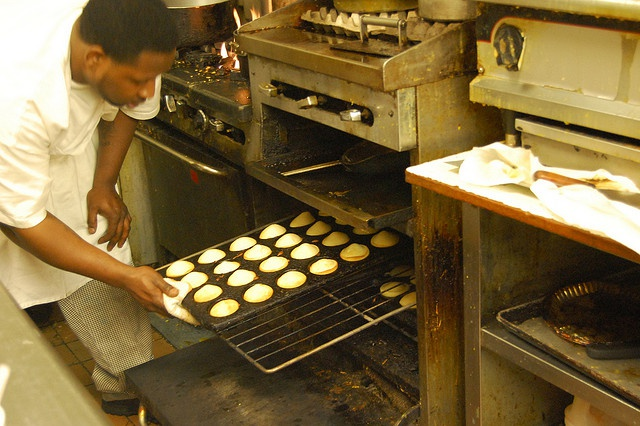Describe the objects in this image and their specific colors. I can see oven in ivory, black, olive, and maroon tones, people in ivory, khaki, and olive tones, and oven in ivory, black, and olive tones in this image. 